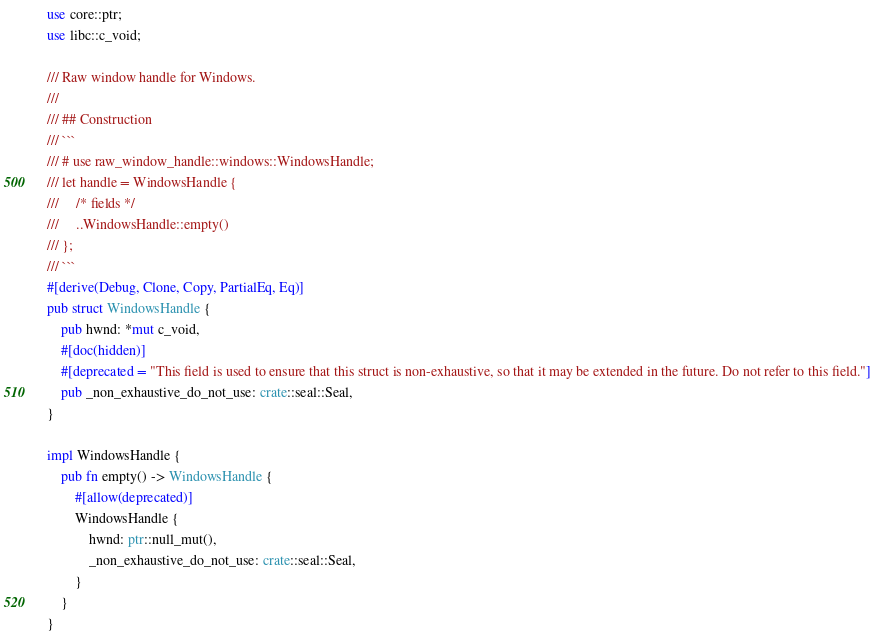Convert code to text. <code><loc_0><loc_0><loc_500><loc_500><_Rust_>use core::ptr;
use libc::c_void;

/// Raw window handle for Windows.
///
/// ## Construction
/// ```
/// # use raw_window_handle::windows::WindowsHandle;
/// let handle = WindowsHandle {
///     /* fields */
///     ..WindowsHandle::empty()
/// };
/// ```
#[derive(Debug, Clone, Copy, PartialEq, Eq)]
pub struct WindowsHandle {
    pub hwnd: *mut c_void,
    #[doc(hidden)]
    #[deprecated = "This field is used to ensure that this struct is non-exhaustive, so that it may be extended in the future. Do not refer to this field."]
    pub _non_exhaustive_do_not_use: crate::seal::Seal,
}

impl WindowsHandle {
    pub fn empty() -> WindowsHandle {
        #[allow(deprecated)]
        WindowsHandle {
            hwnd: ptr::null_mut(),
            _non_exhaustive_do_not_use: crate::seal::Seal,
        }
    }
}
</code> 